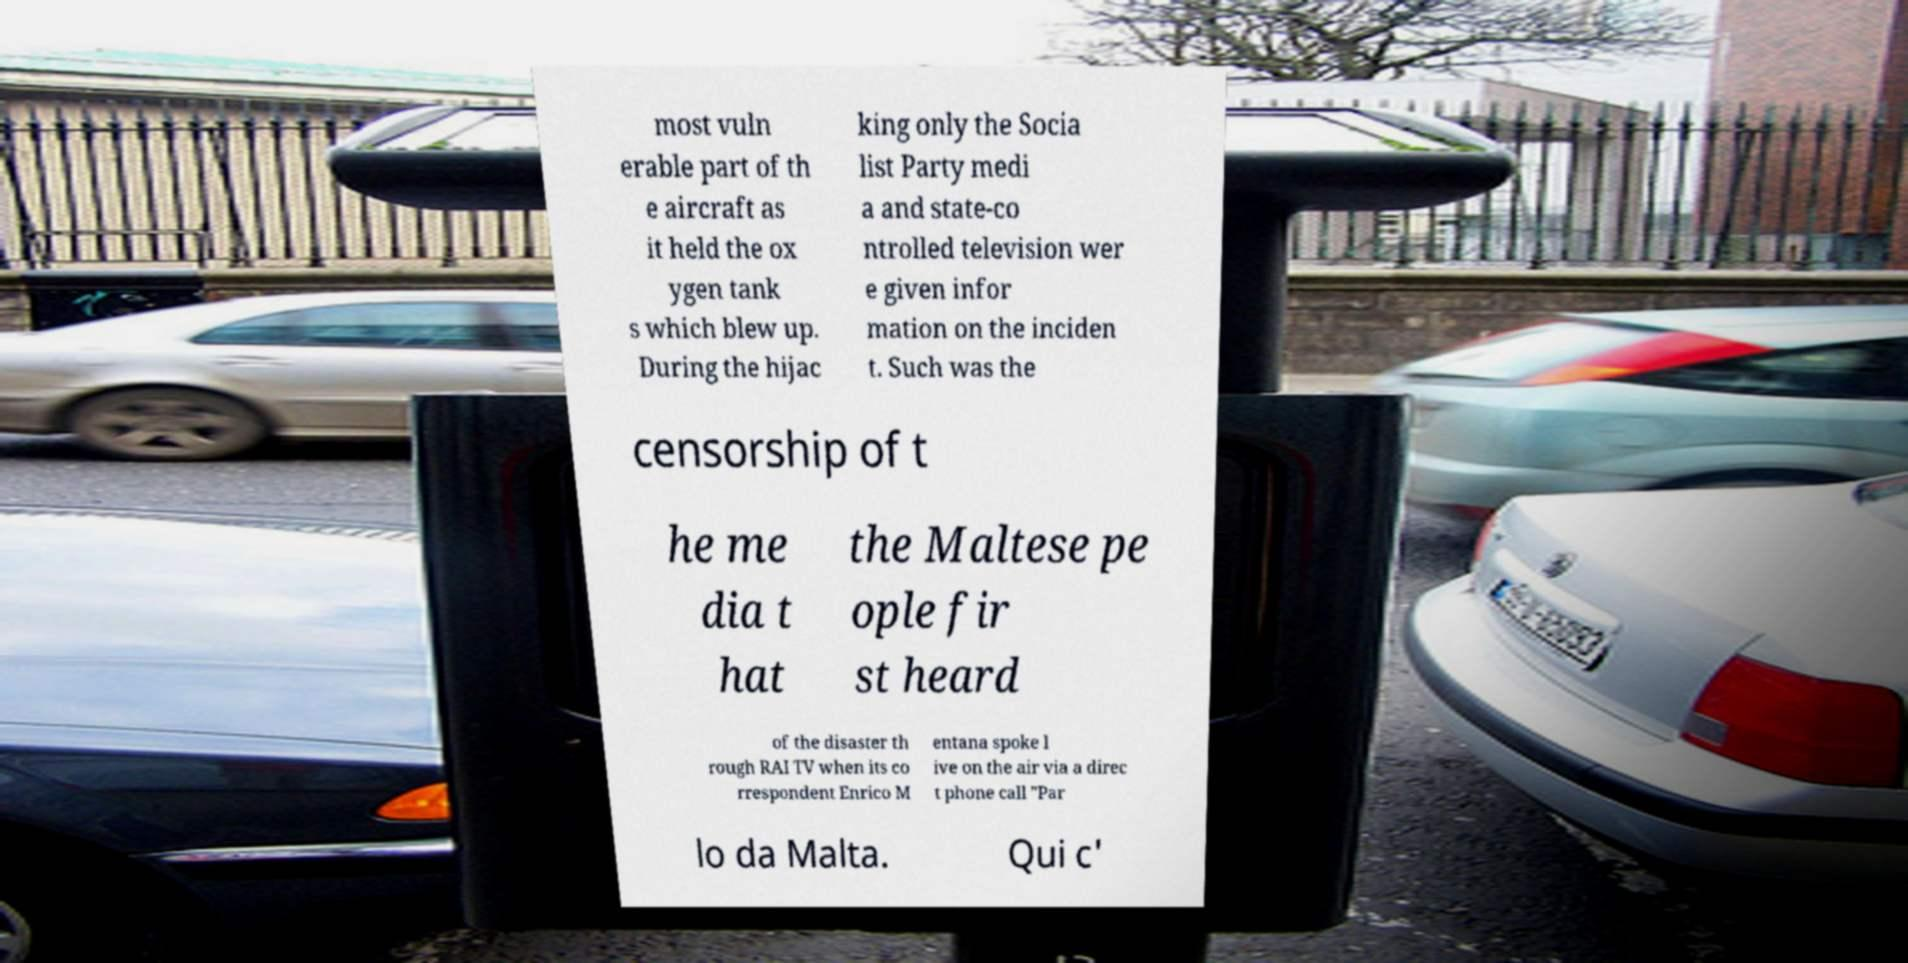Can you accurately transcribe the text from the provided image for me? most vuln erable part of th e aircraft as it held the ox ygen tank s which blew up. During the hijac king only the Socia list Party medi a and state-co ntrolled television wer e given infor mation on the inciden t. Such was the censorship of t he me dia t hat the Maltese pe ople fir st heard of the disaster th rough RAI TV when its co rrespondent Enrico M entana spoke l ive on the air via a direc t phone call "Par lo da Malta. Qui c' 